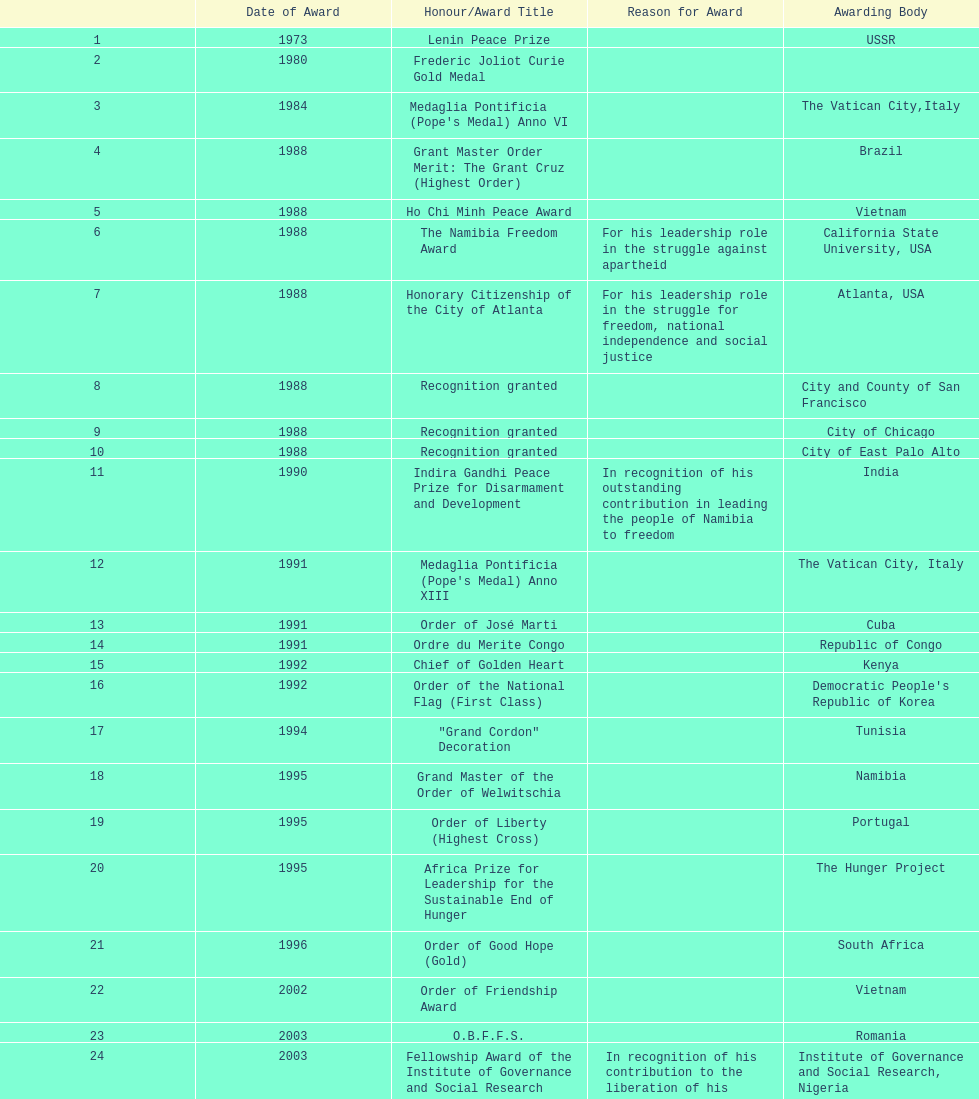What is the disparity between the quantity of awards won in 1988 and the quantity of awards won in 1995? 4. 